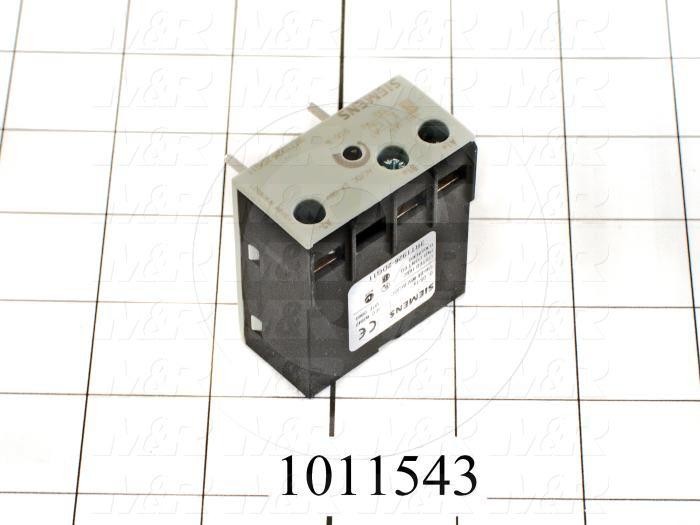Based on the label visible on the side of the electrical component, what can be inferred about the type of applications this component is suited for, considering its ampere rating and the other information provided? The label on the electrical component indicates a 16 A rating, which suggests it is suitable for applications that require handling moderate current, such as small motors, lighting circuits, or heating elements commonly found in residential or commercial settings. The design and form factor of the component indicate that it is used to switch on and off electrical circuits, controlling the power flow to various devices. The absence of features meant for high-current applications, such as heavy-duty connectors or heat dissipation mechanisms, implies this component is not intended for heavy industrial use but rather for general-purpose electrical control within its rated capacity. Additionally, given the branding visible on the component and the standard certifications, it can be inferred that this component adheres to industry standards for safety and quality, making it reliable for the described applications. 